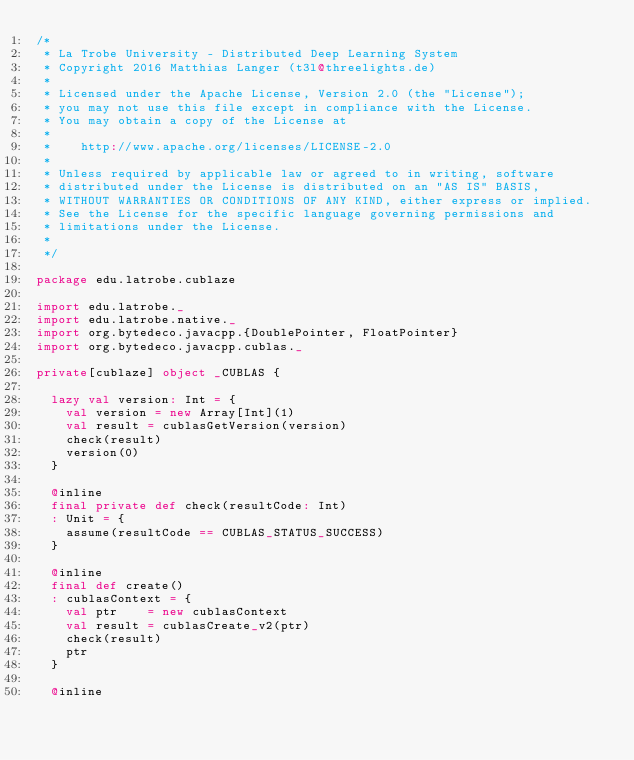<code> <loc_0><loc_0><loc_500><loc_500><_Scala_>/*
 * La Trobe University - Distributed Deep Learning System
 * Copyright 2016 Matthias Langer (t3l@threelights.de)
 *
 * Licensed under the Apache License, Version 2.0 (the "License");
 * you may not use this file except in compliance with the License.
 * You may obtain a copy of the License at
 *
 *    http://www.apache.org/licenses/LICENSE-2.0
 *
 * Unless required by applicable law or agreed to in writing, software
 * distributed under the License is distributed on an "AS IS" BASIS,
 * WITHOUT WARRANTIES OR CONDITIONS OF ANY KIND, either express or implied.
 * See the License for the specific language governing permissions and
 * limitations under the License.
 *
 */

package edu.latrobe.cublaze

import edu.latrobe._
import edu.latrobe.native._
import org.bytedeco.javacpp.{DoublePointer, FloatPointer}
import org.bytedeco.javacpp.cublas._

private[cublaze] object _CUBLAS {

  lazy val version: Int = {
    val version = new Array[Int](1)
    val result = cublasGetVersion(version)
    check(result)
    version(0)
  }

  @inline
  final private def check(resultCode: Int)
  : Unit = {
    assume(resultCode == CUBLAS_STATUS_SUCCESS)
  }

  @inline
  final def create()
  : cublasContext = {
    val ptr    = new cublasContext
    val result = cublasCreate_v2(ptr)
    check(result)
    ptr
  }

  @inline</code> 